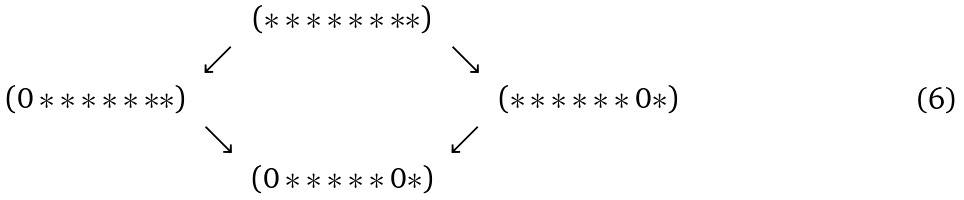<formula> <loc_0><loc_0><loc_500><loc_500>\begin{matrix} & & ( * * * * * * * * ) & & \\ & \swarrow & & \searrow & \\ ( 0 * * * * * * * ) & & & & ( * * * * * * 0 * ) \\ & \searrow & & \swarrow & \\ & & ( 0 * * * * * 0 * ) & & \end{matrix}</formula> 